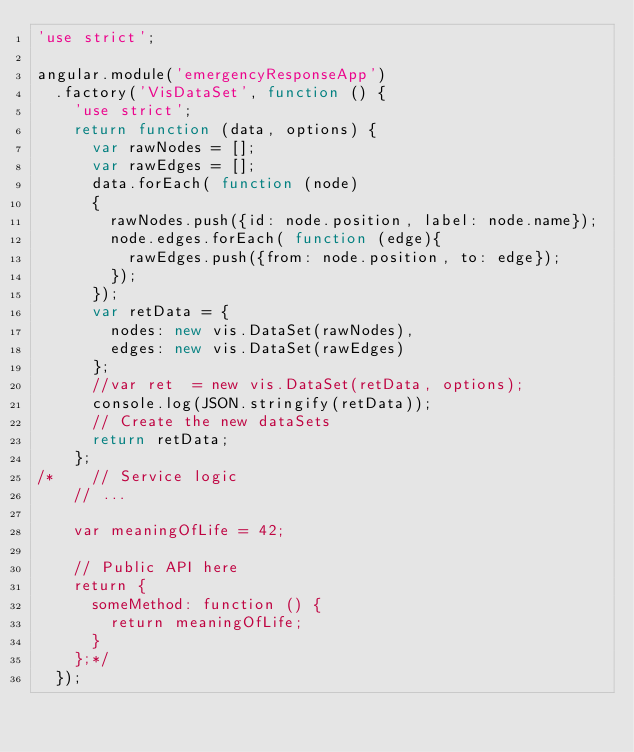Convert code to text. <code><loc_0><loc_0><loc_500><loc_500><_JavaScript_>'use strict';

angular.module('emergencyResponseApp')
  .factory('VisDataSet', function () {
    'use strict';
    return function (data, options) {
      var rawNodes = [];
      var rawEdges = [];
      data.forEach( function (node)
      {
        rawNodes.push({id: node.position, label: node.name});
        node.edges.forEach( function (edge){
          rawEdges.push({from: node.position, to: edge});
        });
      });
      var retData = {
        nodes: new vis.DataSet(rawNodes),
        edges: new vis.DataSet(rawEdges)
      };
      //var ret  = new vis.DataSet(retData, options);
      console.log(JSON.stringify(retData));
      // Create the new dataSets
      return retData;
    };
/*    // Service logic
    // ...

    var meaningOfLife = 42;

    // Public API here
    return {
      someMethod: function () {
        return meaningOfLife;
      }
    };*/
  });

</code> 